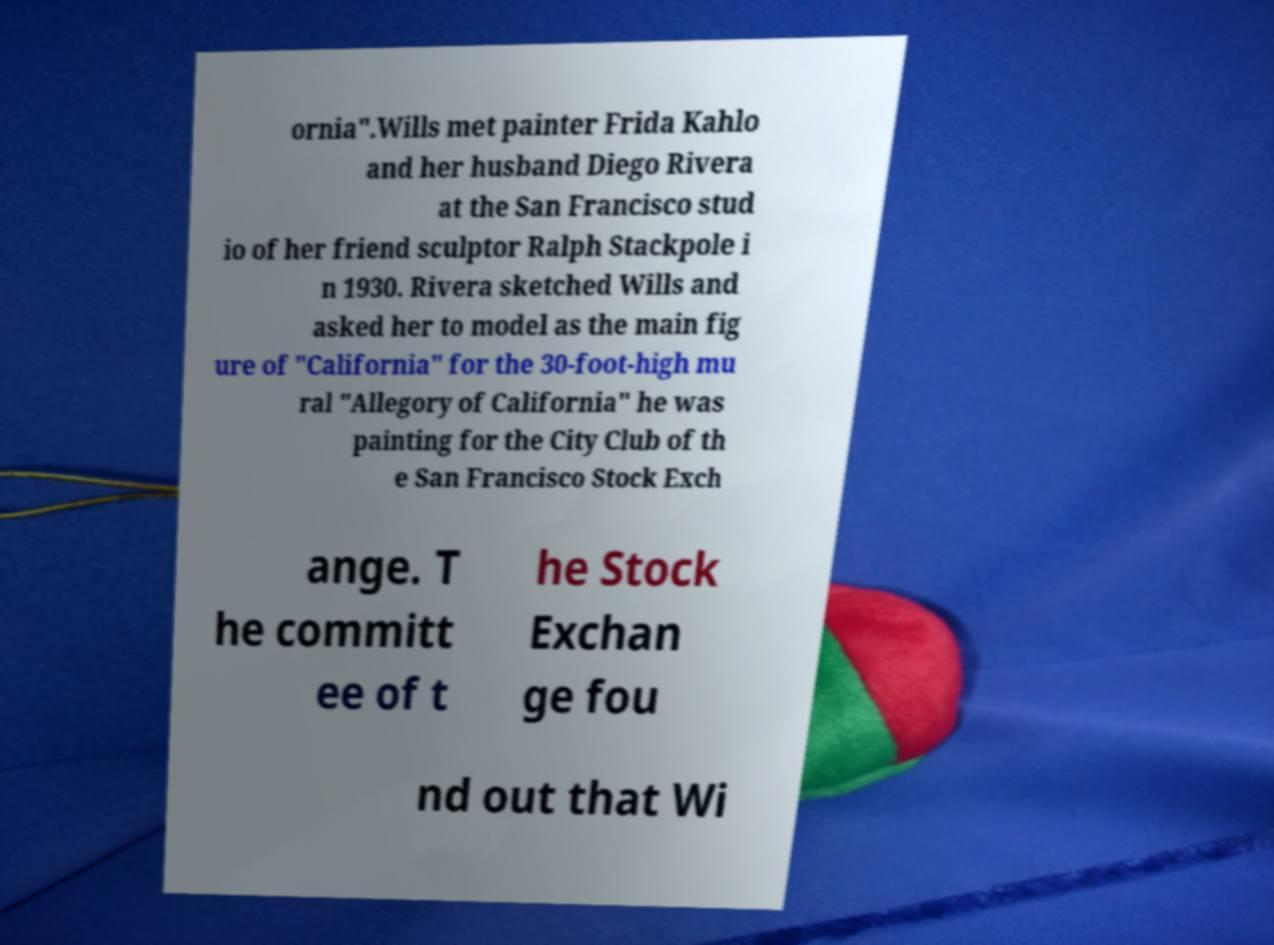Please identify and transcribe the text found in this image. ornia".Wills met painter Frida Kahlo and her husband Diego Rivera at the San Francisco stud io of her friend sculptor Ralph Stackpole i n 1930. Rivera sketched Wills and asked her to model as the main fig ure of "California" for the 30-foot-high mu ral "Allegory of California" he was painting for the City Club of th e San Francisco Stock Exch ange. T he committ ee of t he Stock Exchan ge fou nd out that Wi 